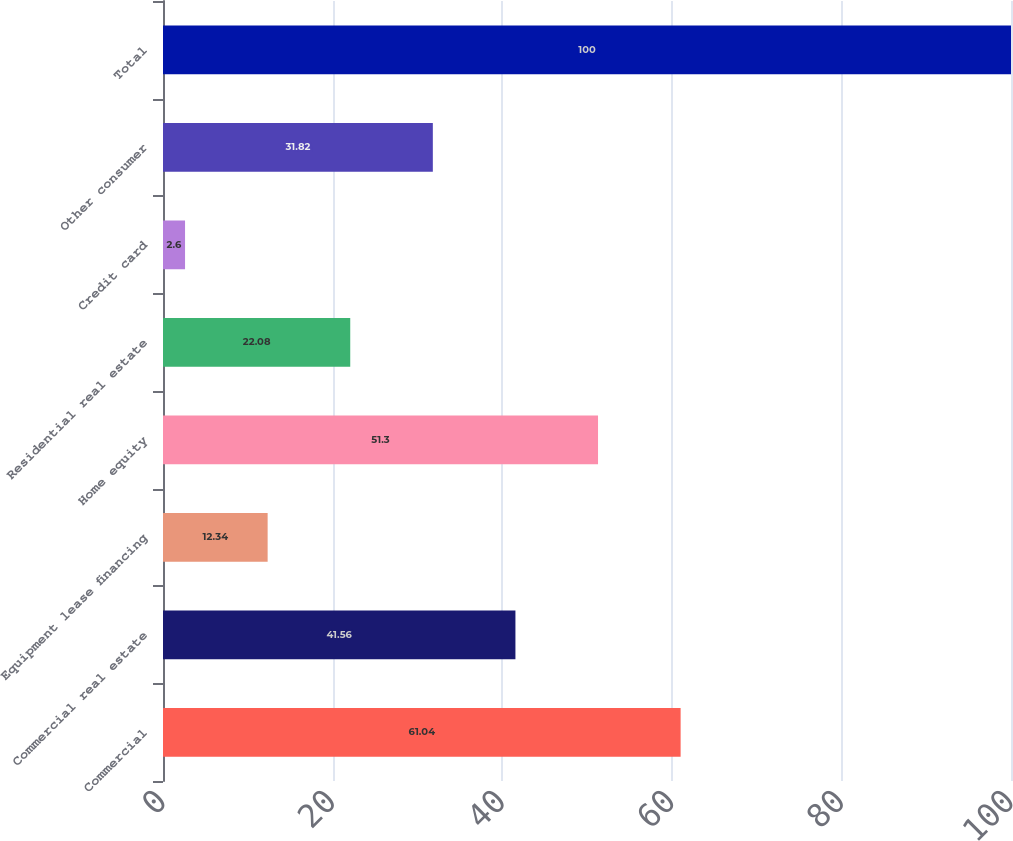Convert chart to OTSL. <chart><loc_0><loc_0><loc_500><loc_500><bar_chart><fcel>Commercial<fcel>Commercial real estate<fcel>Equipment lease financing<fcel>Home equity<fcel>Residential real estate<fcel>Credit card<fcel>Other consumer<fcel>Total<nl><fcel>61.04<fcel>41.56<fcel>12.34<fcel>51.3<fcel>22.08<fcel>2.6<fcel>31.82<fcel>100<nl></chart> 